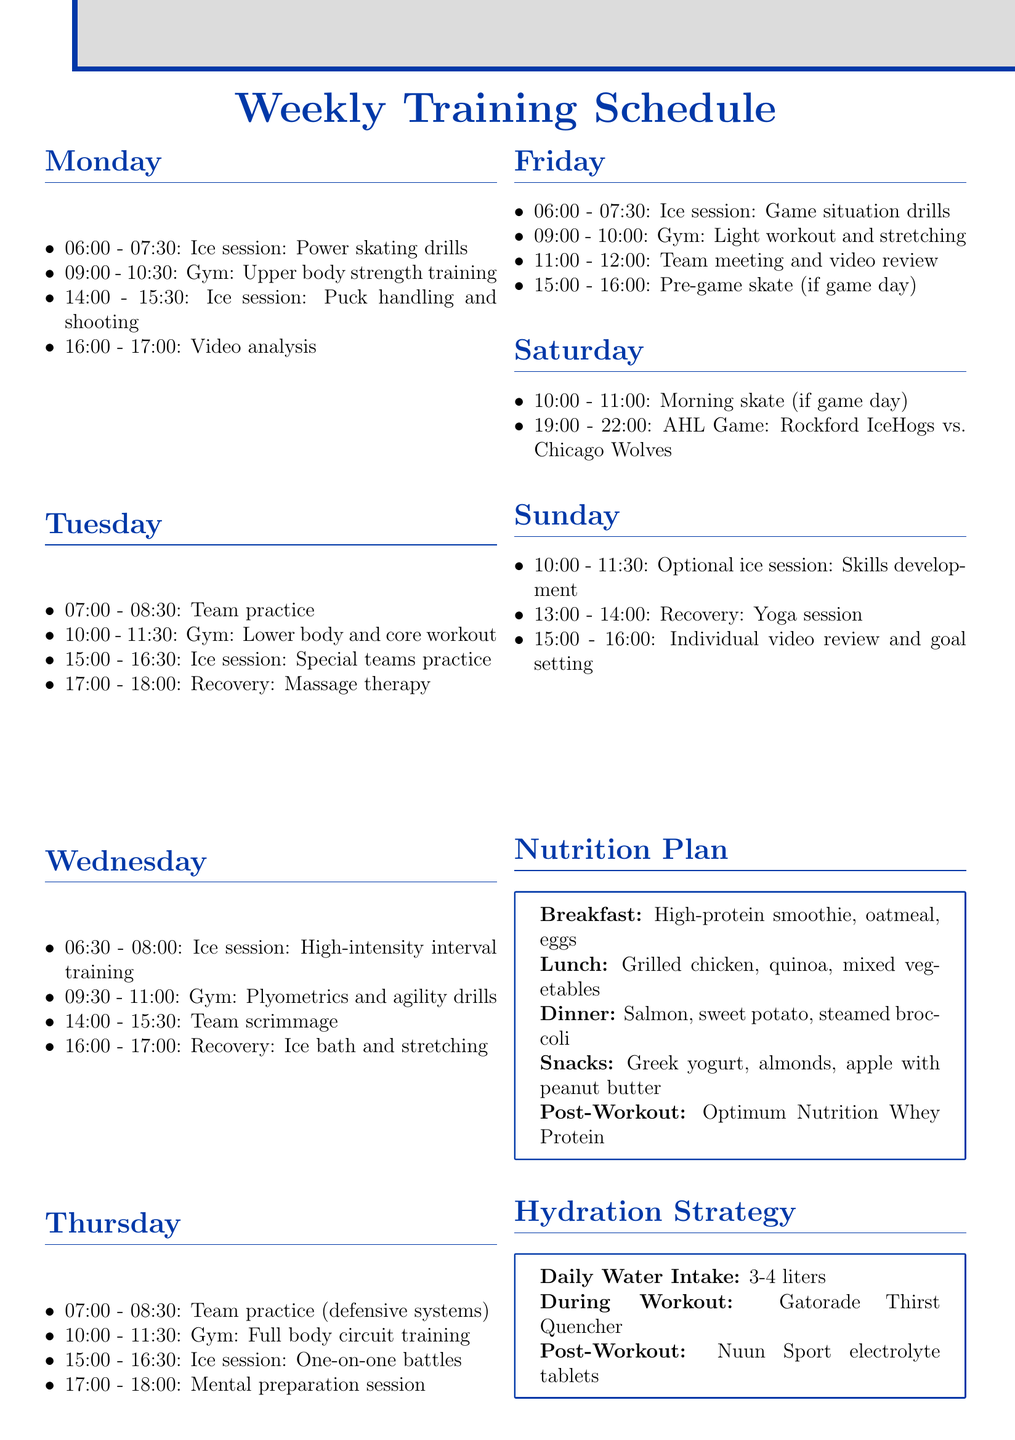What time does the ice session start on Monday? The ice session starts at 06:00 on Monday.
Answer: 06:00 What activity is scheduled for Tuesday at 15:00? The activity scheduled for Tuesday at 15:00 is Special teams practice.
Answer: Special teams practice How many hours of gym sessions are there on Wednesday? There are two gym sessions on Wednesday, one from 09:30 to 11:00, which is 1.5 hours, and another one preceding the scrimmage.
Answer: 1.5 hours What is the total number of activities scheduled on Friday? The total number of activities scheduled on Friday is four, including various sessions from morning to pre-game.
Answer: 4 What type of session is included in the recovery period on Tuesday? The recovery period on Tuesday includes massage therapy.
Answer: Massage therapy How long is the ice session on Thursday? The ice session on Thursday lasts for 1.5 hours, from 15:00 to 16:30.
Answer: 1.5 hours What nutrition plan is suggested for breakfast? The breakfast suggested in the nutrition plan includes a high-protein smoothie, oatmeal with berries, and scrambled eggs.
Answer: High-protein smoothie, oatmeal with berries, and scrambled eggs What is the name of the Team Physiotherapist mentioned in the schedule? The name of the Team Physiotherapist is Lisa Garcia.
Answer: Lisa Garcia What is scheduled for Sunday between 10:00 and 11:30? An optional ice session focusing on skills development is scheduled for that time.
Answer: Optional ice session: Skills development 